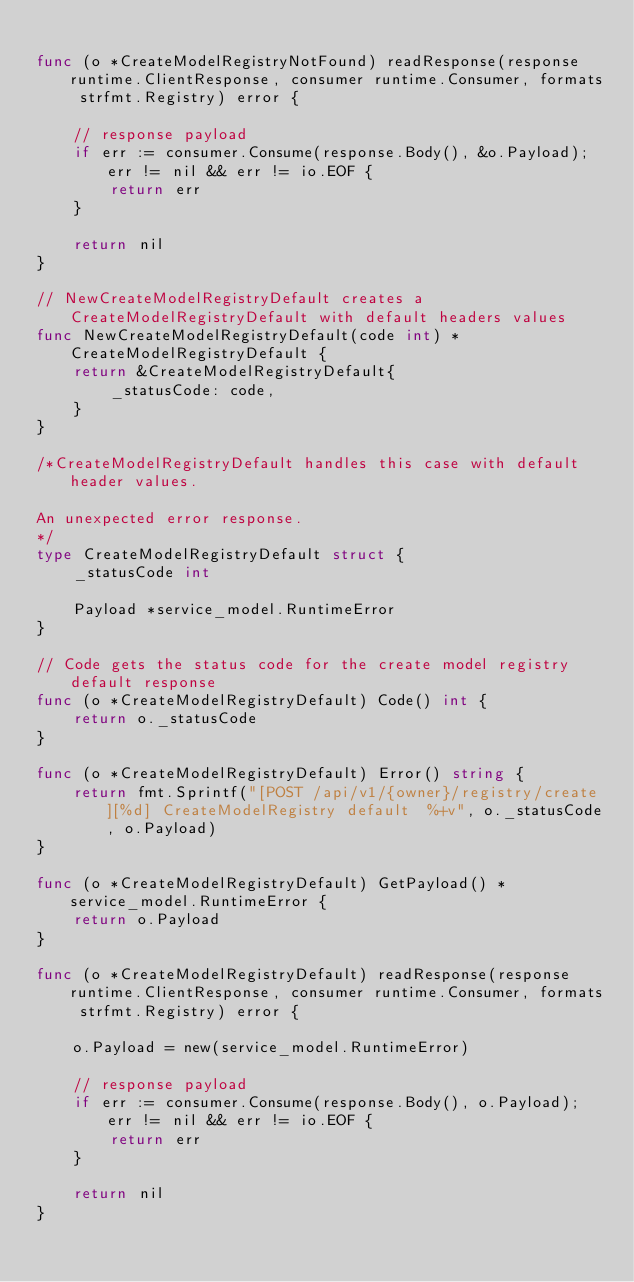<code> <loc_0><loc_0><loc_500><loc_500><_Go_>
func (o *CreateModelRegistryNotFound) readResponse(response runtime.ClientResponse, consumer runtime.Consumer, formats strfmt.Registry) error {

	// response payload
	if err := consumer.Consume(response.Body(), &o.Payload); err != nil && err != io.EOF {
		return err
	}

	return nil
}

// NewCreateModelRegistryDefault creates a CreateModelRegistryDefault with default headers values
func NewCreateModelRegistryDefault(code int) *CreateModelRegistryDefault {
	return &CreateModelRegistryDefault{
		_statusCode: code,
	}
}

/*CreateModelRegistryDefault handles this case with default header values.

An unexpected error response.
*/
type CreateModelRegistryDefault struct {
	_statusCode int

	Payload *service_model.RuntimeError
}

// Code gets the status code for the create model registry default response
func (o *CreateModelRegistryDefault) Code() int {
	return o._statusCode
}

func (o *CreateModelRegistryDefault) Error() string {
	return fmt.Sprintf("[POST /api/v1/{owner}/registry/create][%d] CreateModelRegistry default  %+v", o._statusCode, o.Payload)
}

func (o *CreateModelRegistryDefault) GetPayload() *service_model.RuntimeError {
	return o.Payload
}

func (o *CreateModelRegistryDefault) readResponse(response runtime.ClientResponse, consumer runtime.Consumer, formats strfmt.Registry) error {

	o.Payload = new(service_model.RuntimeError)

	// response payload
	if err := consumer.Consume(response.Body(), o.Payload); err != nil && err != io.EOF {
		return err
	}

	return nil
}
</code> 